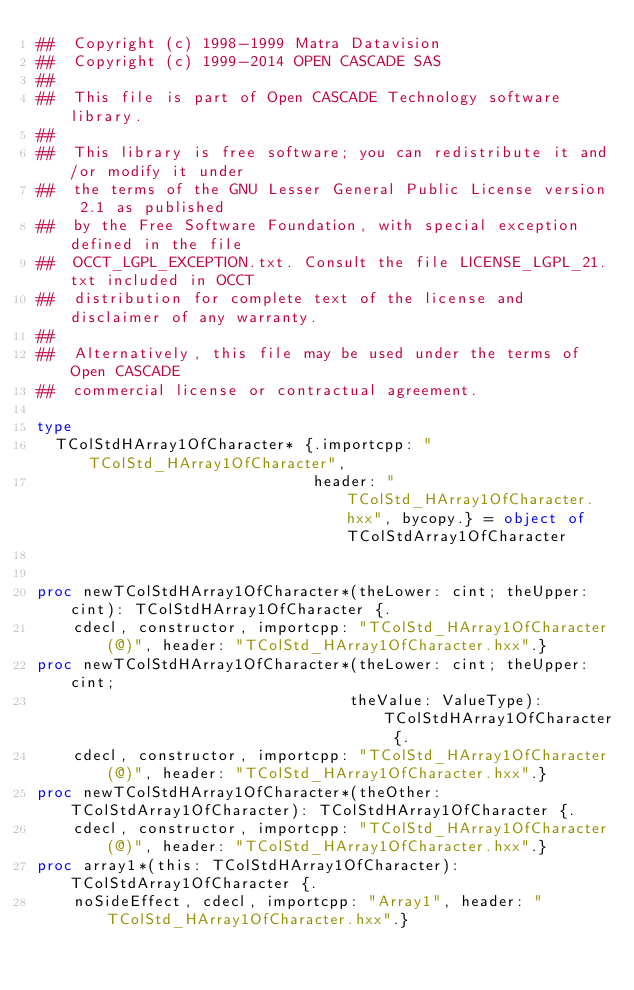Convert code to text. <code><loc_0><loc_0><loc_500><loc_500><_Nim_>##  Copyright (c) 1998-1999 Matra Datavision
##  Copyright (c) 1999-2014 OPEN CASCADE SAS
##
##  This file is part of Open CASCADE Technology software library.
##
##  This library is free software; you can redistribute it and/or modify it under
##  the terms of the GNU Lesser General Public License version 2.1 as published
##  by the Free Software Foundation, with special exception defined in the file
##  OCCT_LGPL_EXCEPTION.txt. Consult the file LICENSE_LGPL_21.txt included in OCCT
##  distribution for complete text of the license and disclaimer of any warranty.
##
##  Alternatively, this file may be used under the terms of Open CASCADE
##  commercial license or contractual agreement.

type
  TColStdHArray1OfCharacter* {.importcpp: "TColStd_HArray1OfCharacter",
                              header: "TColStd_HArray1OfCharacter.hxx", bycopy.} = object of TColStdArray1OfCharacter


proc newTColStdHArray1OfCharacter*(theLower: cint; theUpper: cint): TColStdHArray1OfCharacter {.
    cdecl, constructor, importcpp: "TColStd_HArray1OfCharacter(@)", header: "TColStd_HArray1OfCharacter.hxx".}
proc newTColStdHArray1OfCharacter*(theLower: cint; theUpper: cint;
                                  theValue: ValueType): TColStdHArray1OfCharacter {.
    cdecl, constructor, importcpp: "TColStd_HArray1OfCharacter(@)", header: "TColStd_HArray1OfCharacter.hxx".}
proc newTColStdHArray1OfCharacter*(theOther: TColStdArray1OfCharacter): TColStdHArray1OfCharacter {.
    cdecl, constructor, importcpp: "TColStd_HArray1OfCharacter(@)", header: "TColStd_HArray1OfCharacter.hxx".}
proc array1*(this: TColStdHArray1OfCharacter): TColStdArray1OfCharacter {.
    noSideEffect, cdecl, importcpp: "Array1", header: "TColStd_HArray1OfCharacter.hxx".}</code> 